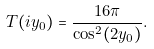<formula> <loc_0><loc_0><loc_500><loc_500>T ( i y _ { 0 } ) = \frac { 1 6 \pi } { \cos ^ { 2 } ( 2 y _ { 0 } ) } .</formula> 